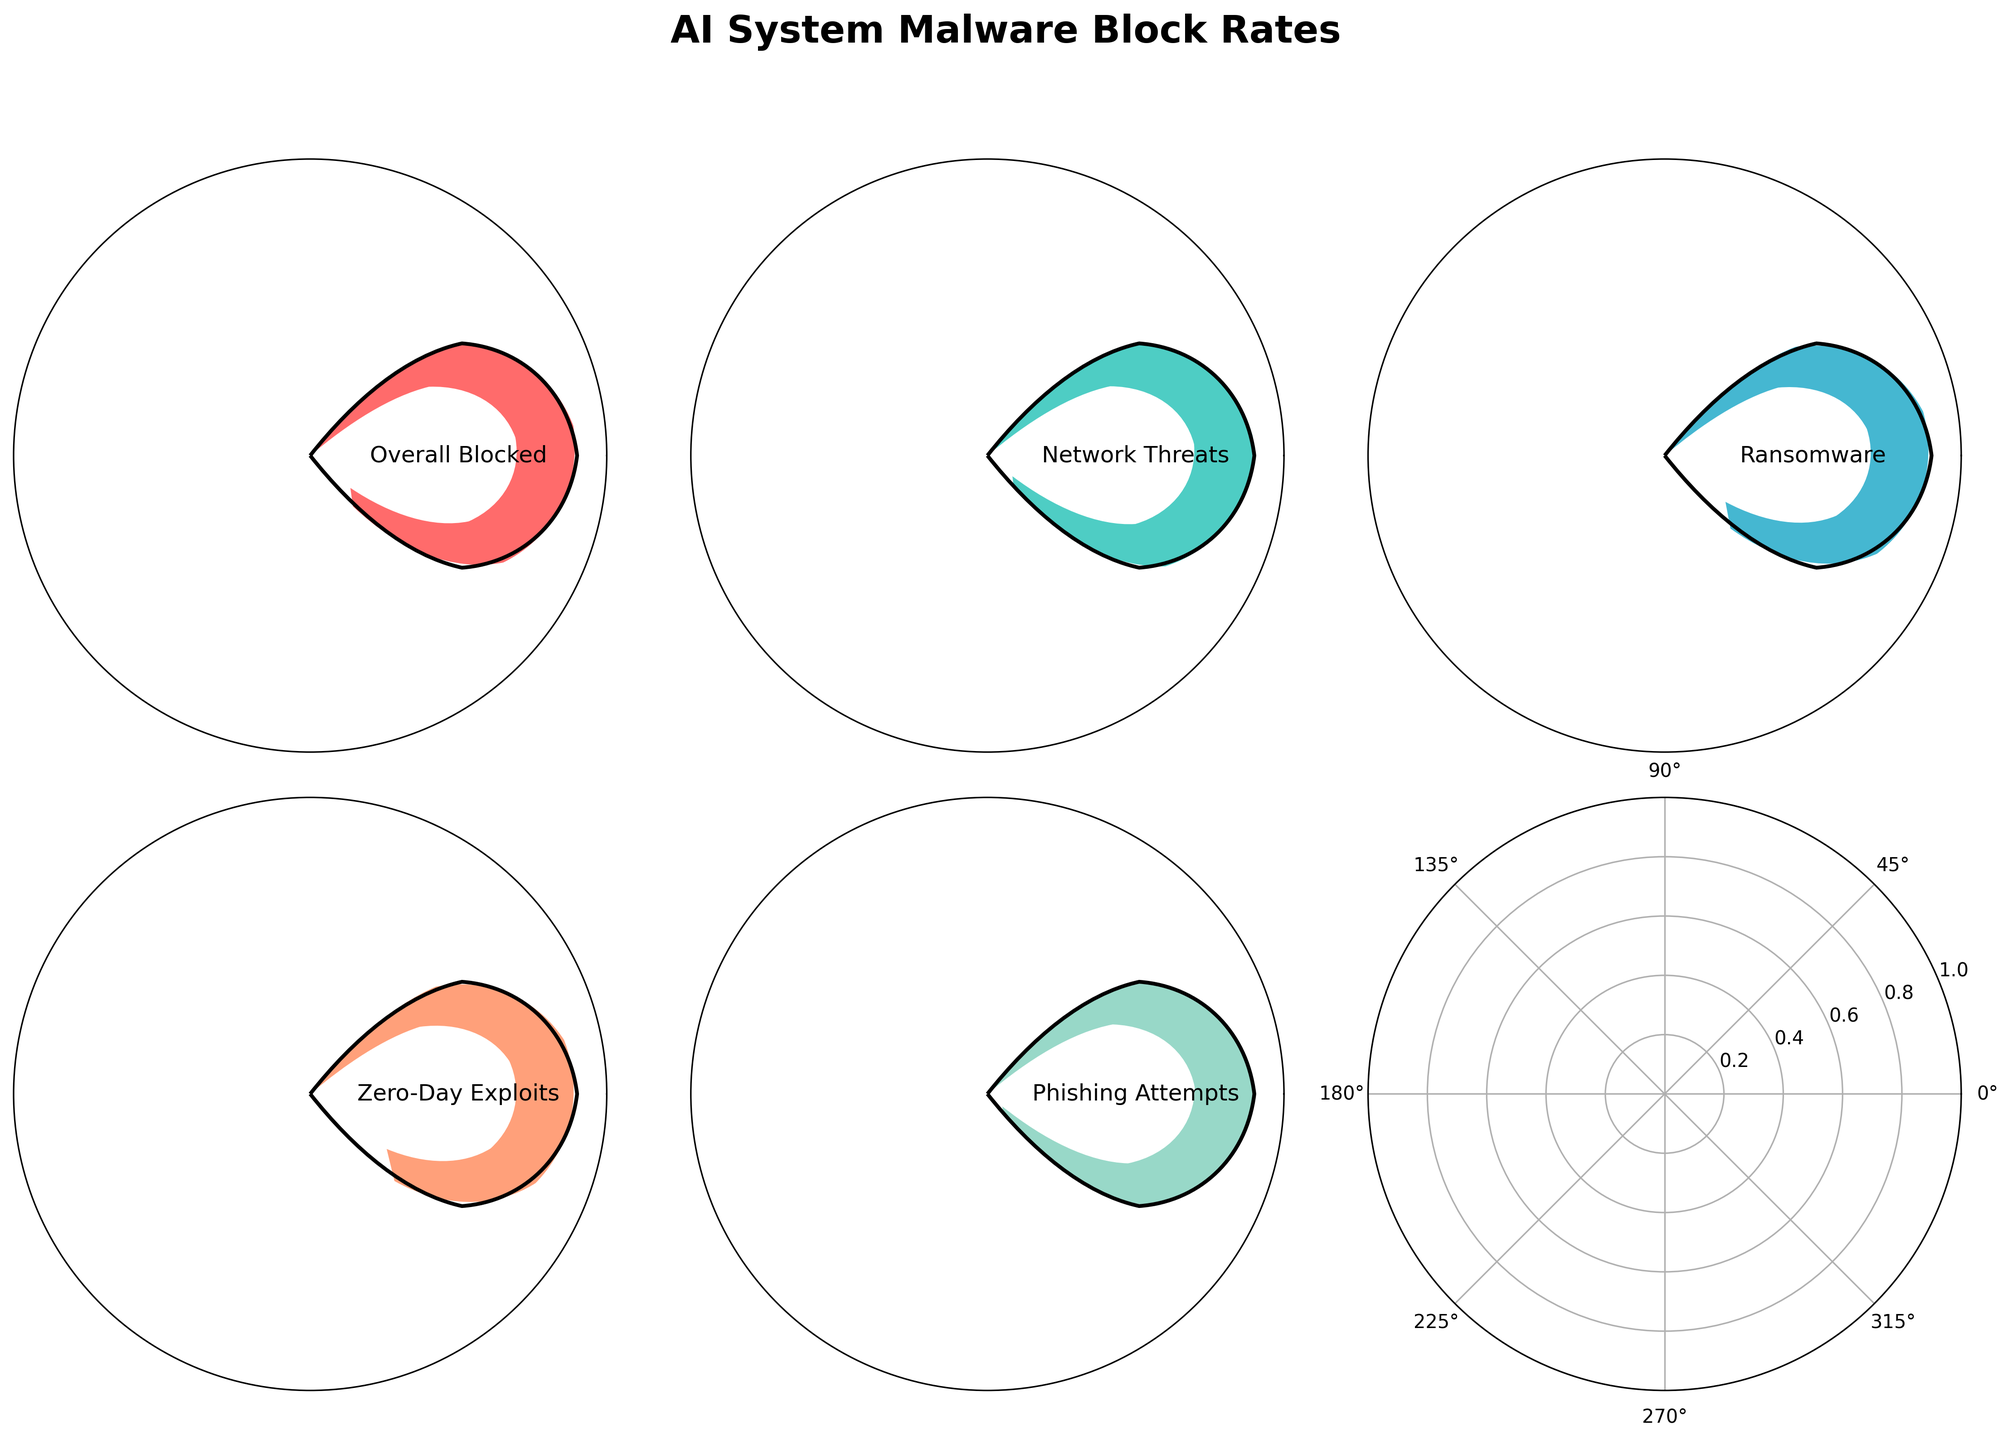What is the percentage of successfully blocked ransomware attacks? The chart labeled "Ransomware" shows the blocked percentage directly.
Answer: 88% Which category has the highest percentage of successfully blocked attacks? By comparing the values in each gauge, "Phishing Attempts" has the highest blocked rate.
Answer: Phishing Attempts What is the average percentage of successfully blocked overall attacks across all categories? To find the average, sum up all the percentages presented (92 + 95 + 88 + 85 + 97) and divide by the number of categories (5). The calculation is: (92 + 95 + 88 + 85 + 97) / 5 = 91.4
Answer: 91.4% Which category has the lowest percentage of successfully blocked attacks? By comparing the values in each gauge, "Zero-Day Exploits" has the lowest blocked rate.
Answer: Zero-Day Exploits How many categories have a blocked percentage higher than 90%? Count the number of categories with blocked rates over 90. "Overall Blocked" (92), "Network Threats" (95), and "Phishing Attempts" (97) make three categories.
Answer: 3 